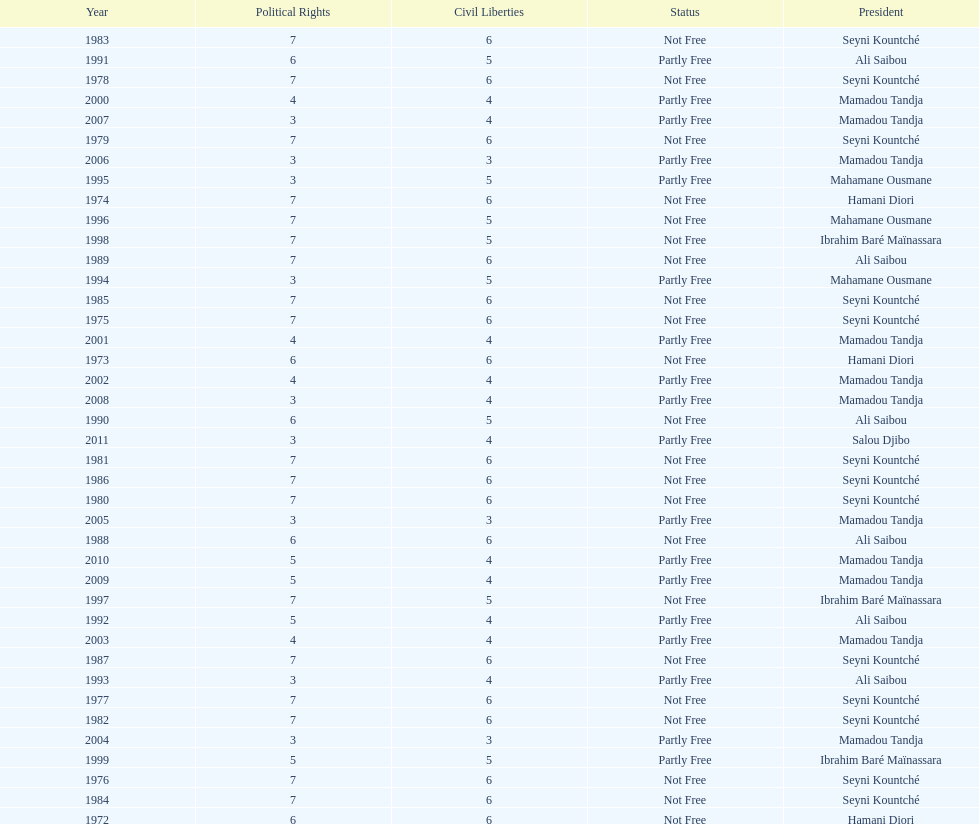Who is the next president listed after hamani diori in the year 1974? Seyni Kountché. 